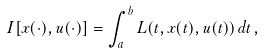<formula> <loc_0><loc_0><loc_500><loc_500>I [ x ( \cdot ) , u ( \cdot ) ] = \int _ { a } ^ { b } L ( t , x ( t ) , u ( t ) ) \, d t \, ,</formula> 